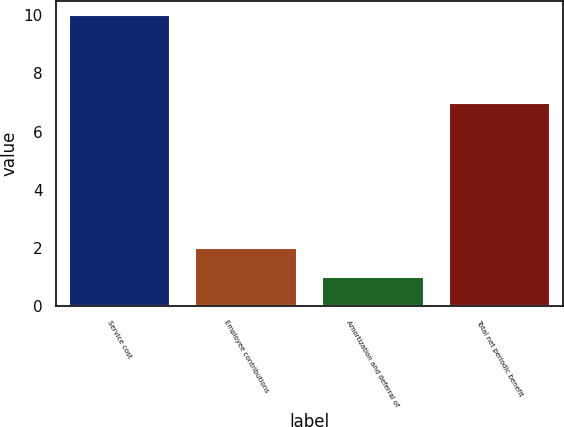<chart> <loc_0><loc_0><loc_500><loc_500><bar_chart><fcel>Service cost<fcel>Employee contributions<fcel>Amortization and deferral of<fcel>Total net periodic benefit<nl><fcel>10<fcel>2<fcel>1<fcel>7<nl></chart> 